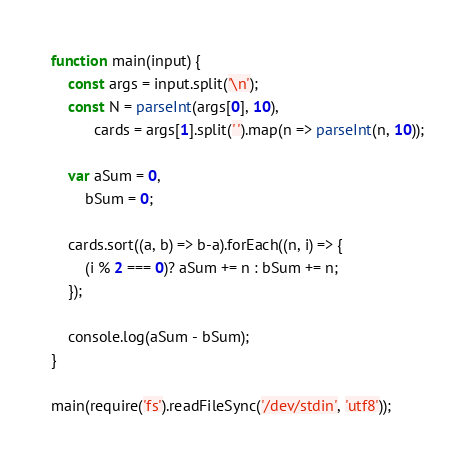<code> <loc_0><loc_0><loc_500><loc_500><_JavaScript_>function main(input) {
    const args = input.split('\n');
    const N = parseInt(args[0], 10),
          cards = args[1].split(' ').map(n => parseInt(n, 10));

    var aSum = 0,
        bSum = 0;

    cards.sort((a, b) => b-a).forEach((n, i) => {
        (i % 2 === 0)? aSum += n : bSum += n;
    });

    console.log(aSum - bSum);
}

main(require('fs').readFileSync('/dev/stdin', 'utf8'));
</code> 